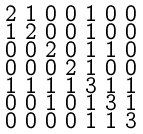Convert formula to latex. <formula><loc_0><loc_0><loc_500><loc_500>\begin{smallmatrix} 2 & 1 & 0 & 0 & 1 & 0 & 0 \\ 1 & 2 & 0 & 0 & 1 & 0 & 0 \\ 0 & 0 & 2 & 0 & 1 & 1 & 0 \\ 0 & 0 & 0 & 2 & 1 & 0 & 0 \\ 1 & 1 & 1 & 1 & 3 & 1 & 1 \\ 0 & 0 & 1 & 0 & 1 & 3 & 1 \\ 0 & 0 & 0 & 0 & 1 & 1 & 3 \end{smallmatrix}</formula> 